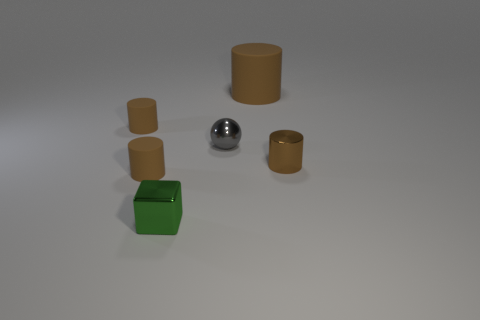Subtract all cyan cylinders. Subtract all purple balls. How many cylinders are left? 4 Add 2 blue matte spheres. How many objects exist? 8 Subtract all blocks. How many objects are left? 5 Subtract all tiny matte balls. Subtract all tiny brown rubber things. How many objects are left? 4 Add 1 brown matte cylinders. How many brown matte cylinders are left? 4 Add 3 big cylinders. How many big cylinders exist? 4 Subtract 0 gray cylinders. How many objects are left? 6 